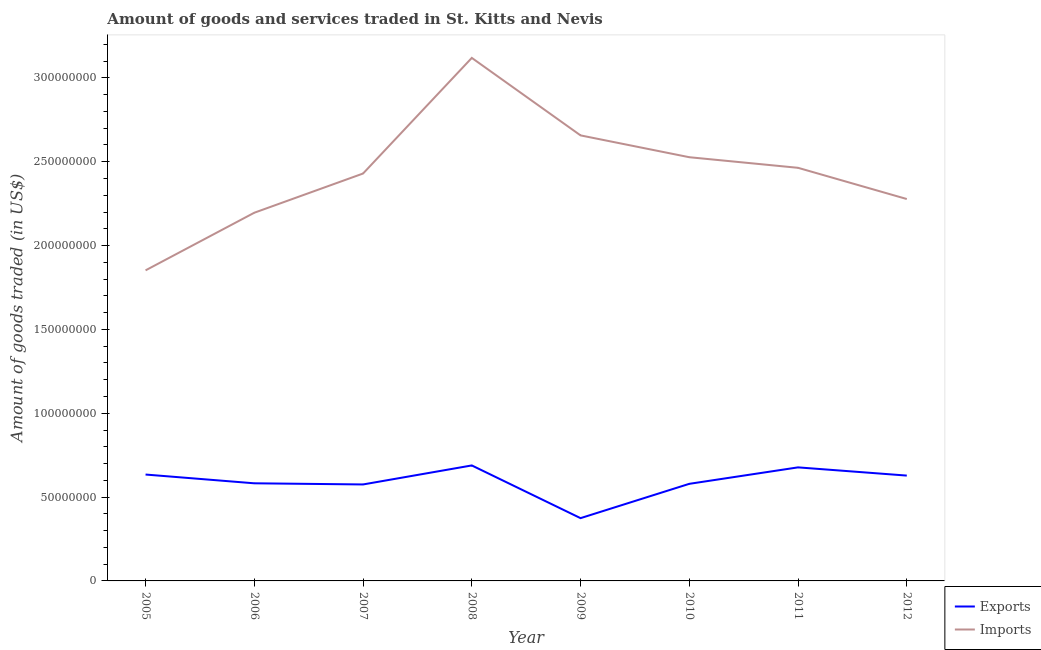Does the line corresponding to amount of goods imported intersect with the line corresponding to amount of goods exported?
Give a very brief answer. No. What is the amount of goods imported in 2008?
Make the answer very short. 3.12e+08. Across all years, what is the maximum amount of goods imported?
Your response must be concise. 3.12e+08. Across all years, what is the minimum amount of goods exported?
Make the answer very short. 3.74e+07. What is the total amount of goods imported in the graph?
Ensure brevity in your answer.  1.95e+09. What is the difference between the amount of goods imported in 2006 and that in 2011?
Ensure brevity in your answer.  -2.68e+07. What is the difference between the amount of goods imported in 2010 and the amount of goods exported in 2009?
Your answer should be compact. 2.15e+08. What is the average amount of goods imported per year?
Offer a very short reply. 2.44e+08. In the year 2009, what is the difference between the amount of goods exported and amount of goods imported?
Your answer should be very brief. -2.28e+08. What is the ratio of the amount of goods imported in 2005 to that in 2011?
Your response must be concise. 0.75. Is the difference between the amount of goods imported in 2008 and 2010 greater than the difference between the amount of goods exported in 2008 and 2010?
Give a very brief answer. Yes. What is the difference between the highest and the second highest amount of goods imported?
Provide a short and direct response. 4.62e+07. What is the difference between the highest and the lowest amount of goods imported?
Provide a succinct answer. 1.27e+08. Is the sum of the amount of goods imported in 2007 and 2008 greater than the maximum amount of goods exported across all years?
Ensure brevity in your answer.  Yes. Does the amount of goods imported monotonically increase over the years?
Ensure brevity in your answer.  No. Is the amount of goods exported strictly greater than the amount of goods imported over the years?
Provide a succinct answer. No. Is the amount of goods exported strictly less than the amount of goods imported over the years?
Make the answer very short. Yes. What is the difference between two consecutive major ticks on the Y-axis?
Ensure brevity in your answer.  5.00e+07. Does the graph contain any zero values?
Provide a short and direct response. No. How many legend labels are there?
Keep it short and to the point. 2. What is the title of the graph?
Give a very brief answer. Amount of goods and services traded in St. Kitts and Nevis. What is the label or title of the Y-axis?
Ensure brevity in your answer.  Amount of goods traded (in US$). What is the Amount of goods traded (in US$) of Exports in 2005?
Offer a terse response. 6.34e+07. What is the Amount of goods traded (in US$) in Imports in 2005?
Give a very brief answer. 1.85e+08. What is the Amount of goods traded (in US$) in Exports in 2006?
Your answer should be very brief. 5.82e+07. What is the Amount of goods traded (in US$) of Imports in 2006?
Keep it short and to the point. 2.20e+08. What is the Amount of goods traded (in US$) of Exports in 2007?
Give a very brief answer. 5.75e+07. What is the Amount of goods traded (in US$) of Imports in 2007?
Provide a succinct answer. 2.43e+08. What is the Amount of goods traded (in US$) in Exports in 2008?
Make the answer very short. 6.89e+07. What is the Amount of goods traded (in US$) of Imports in 2008?
Your answer should be very brief. 3.12e+08. What is the Amount of goods traded (in US$) of Exports in 2009?
Make the answer very short. 3.74e+07. What is the Amount of goods traded (in US$) of Imports in 2009?
Offer a very short reply. 2.66e+08. What is the Amount of goods traded (in US$) in Exports in 2010?
Your response must be concise. 5.79e+07. What is the Amount of goods traded (in US$) of Imports in 2010?
Keep it short and to the point. 2.53e+08. What is the Amount of goods traded (in US$) in Exports in 2011?
Offer a terse response. 6.77e+07. What is the Amount of goods traded (in US$) of Imports in 2011?
Your answer should be very brief. 2.46e+08. What is the Amount of goods traded (in US$) of Exports in 2012?
Your response must be concise. 6.28e+07. What is the Amount of goods traded (in US$) of Imports in 2012?
Ensure brevity in your answer.  2.28e+08. Across all years, what is the maximum Amount of goods traded (in US$) in Exports?
Provide a succinct answer. 6.89e+07. Across all years, what is the maximum Amount of goods traded (in US$) in Imports?
Offer a terse response. 3.12e+08. Across all years, what is the minimum Amount of goods traded (in US$) of Exports?
Ensure brevity in your answer.  3.74e+07. Across all years, what is the minimum Amount of goods traded (in US$) in Imports?
Keep it short and to the point. 1.85e+08. What is the total Amount of goods traded (in US$) in Exports in the graph?
Make the answer very short. 4.74e+08. What is the total Amount of goods traded (in US$) in Imports in the graph?
Offer a terse response. 1.95e+09. What is the difference between the Amount of goods traded (in US$) in Exports in 2005 and that in 2006?
Your response must be concise. 5.23e+06. What is the difference between the Amount of goods traded (in US$) in Imports in 2005 and that in 2006?
Give a very brief answer. -3.44e+07. What is the difference between the Amount of goods traded (in US$) of Exports in 2005 and that in 2007?
Give a very brief answer. 5.92e+06. What is the difference between the Amount of goods traded (in US$) of Imports in 2005 and that in 2007?
Your answer should be very brief. -5.77e+07. What is the difference between the Amount of goods traded (in US$) of Exports in 2005 and that in 2008?
Keep it short and to the point. -5.43e+06. What is the difference between the Amount of goods traded (in US$) of Imports in 2005 and that in 2008?
Your response must be concise. -1.27e+08. What is the difference between the Amount of goods traded (in US$) in Exports in 2005 and that in 2009?
Your answer should be compact. 2.60e+07. What is the difference between the Amount of goods traded (in US$) in Imports in 2005 and that in 2009?
Your answer should be compact. -8.05e+07. What is the difference between the Amount of goods traded (in US$) of Exports in 2005 and that in 2010?
Provide a short and direct response. 5.54e+06. What is the difference between the Amount of goods traded (in US$) in Imports in 2005 and that in 2010?
Make the answer very short. -6.75e+07. What is the difference between the Amount of goods traded (in US$) in Exports in 2005 and that in 2011?
Ensure brevity in your answer.  -4.27e+06. What is the difference between the Amount of goods traded (in US$) in Imports in 2005 and that in 2011?
Provide a succinct answer. -6.11e+07. What is the difference between the Amount of goods traded (in US$) of Exports in 2005 and that in 2012?
Provide a short and direct response. 6.25e+05. What is the difference between the Amount of goods traded (in US$) in Imports in 2005 and that in 2012?
Give a very brief answer. -4.25e+07. What is the difference between the Amount of goods traded (in US$) in Exports in 2006 and that in 2007?
Offer a very short reply. 6.88e+05. What is the difference between the Amount of goods traded (in US$) in Imports in 2006 and that in 2007?
Make the answer very short. -2.34e+07. What is the difference between the Amount of goods traded (in US$) in Exports in 2006 and that in 2008?
Provide a short and direct response. -1.07e+07. What is the difference between the Amount of goods traded (in US$) in Imports in 2006 and that in 2008?
Provide a succinct answer. -9.23e+07. What is the difference between the Amount of goods traded (in US$) of Exports in 2006 and that in 2009?
Keep it short and to the point. 2.08e+07. What is the difference between the Amount of goods traded (in US$) of Imports in 2006 and that in 2009?
Keep it short and to the point. -4.61e+07. What is the difference between the Amount of goods traded (in US$) of Exports in 2006 and that in 2010?
Offer a terse response. 3.13e+05. What is the difference between the Amount of goods traded (in US$) of Imports in 2006 and that in 2010?
Offer a very short reply. -3.31e+07. What is the difference between the Amount of goods traded (in US$) of Exports in 2006 and that in 2011?
Your answer should be very brief. -9.50e+06. What is the difference between the Amount of goods traded (in US$) of Imports in 2006 and that in 2011?
Ensure brevity in your answer.  -2.68e+07. What is the difference between the Amount of goods traded (in US$) of Exports in 2006 and that in 2012?
Provide a succinct answer. -4.60e+06. What is the difference between the Amount of goods traded (in US$) in Imports in 2006 and that in 2012?
Offer a terse response. -8.17e+06. What is the difference between the Amount of goods traded (in US$) in Exports in 2007 and that in 2008?
Give a very brief answer. -1.13e+07. What is the difference between the Amount of goods traded (in US$) of Imports in 2007 and that in 2008?
Offer a very short reply. -6.90e+07. What is the difference between the Amount of goods traded (in US$) of Exports in 2007 and that in 2009?
Your response must be concise. 2.01e+07. What is the difference between the Amount of goods traded (in US$) in Imports in 2007 and that in 2009?
Your response must be concise. -2.27e+07. What is the difference between the Amount of goods traded (in US$) of Exports in 2007 and that in 2010?
Your answer should be compact. -3.75e+05. What is the difference between the Amount of goods traded (in US$) in Imports in 2007 and that in 2010?
Make the answer very short. -9.72e+06. What is the difference between the Amount of goods traded (in US$) in Exports in 2007 and that in 2011?
Offer a terse response. -1.02e+07. What is the difference between the Amount of goods traded (in US$) of Imports in 2007 and that in 2011?
Make the answer very short. -3.40e+06. What is the difference between the Amount of goods traded (in US$) in Exports in 2007 and that in 2012?
Your answer should be compact. -5.29e+06. What is the difference between the Amount of goods traded (in US$) of Imports in 2007 and that in 2012?
Provide a short and direct response. 1.52e+07. What is the difference between the Amount of goods traded (in US$) in Exports in 2008 and that in 2009?
Ensure brevity in your answer.  3.14e+07. What is the difference between the Amount of goods traded (in US$) of Imports in 2008 and that in 2009?
Your response must be concise. 4.62e+07. What is the difference between the Amount of goods traded (in US$) in Exports in 2008 and that in 2010?
Provide a short and direct response. 1.10e+07. What is the difference between the Amount of goods traded (in US$) in Imports in 2008 and that in 2010?
Make the answer very short. 5.92e+07. What is the difference between the Amount of goods traded (in US$) in Exports in 2008 and that in 2011?
Your response must be concise. 1.15e+06. What is the difference between the Amount of goods traded (in US$) in Imports in 2008 and that in 2011?
Ensure brevity in your answer.  6.56e+07. What is the difference between the Amount of goods traded (in US$) in Exports in 2008 and that in 2012?
Give a very brief answer. 6.05e+06. What is the difference between the Amount of goods traded (in US$) of Imports in 2008 and that in 2012?
Your answer should be compact. 8.42e+07. What is the difference between the Amount of goods traded (in US$) in Exports in 2009 and that in 2010?
Offer a terse response. -2.05e+07. What is the difference between the Amount of goods traded (in US$) of Imports in 2009 and that in 2010?
Your answer should be compact. 1.30e+07. What is the difference between the Amount of goods traded (in US$) in Exports in 2009 and that in 2011?
Offer a terse response. -3.03e+07. What is the difference between the Amount of goods traded (in US$) of Imports in 2009 and that in 2011?
Provide a short and direct response. 1.93e+07. What is the difference between the Amount of goods traded (in US$) of Exports in 2009 and that in 2012?
Offer a very short reply. -2.54e+07. What is the difference between the Amount of goods traded (in US$) of Imports in 2009 and that in 2012?
Ensure brevity in your answer.  3.79e+07. What is the difference between the Amount of goods traded (in US$) of Exports in 2010 and that in 2011?
Your answer should be very brief. -9.81e+06. What is the difference between the Amount of goods traded (in US$) of Imports in 2010 and that in 2011?
Keep it short and to the point. 6.32e+06. What is the difference between the Amount of goods traded (in US$) in Exports in 2010 and that in 2012?
Offer a very short reply. -4.91e+06. What is the difference between the Amount of goods traded (in US$) in Imports in 2010 and that in 2012?
Make the answer very short. 2.49e+07. What is the difference between the Amount of goods traded (in US$) in Exports in 2011 and that in 2012?
Provide a succinct answer. 4.90e+06. What is the difference between the Amount of goods traded (in US$) in Imports in 2011 and that in 2012?
Give a very brief answer. 1.86e+07. What is the difference between the Amount of goods traded (in US$) of Exports in 2005 and the Amount of goods traded (in US$) of Imports in 2006?
Provide a succinct answer. -1.56e+08. What is the difference between the Amount of goods traded (in US$) in Exports in 2005 and the Amount of goods traded (in US$) in Imports in 2007?
Keep it short and to the point. -1.80e+08. What is the difference between the Amount of goods traded (in US$) in Exports in 2005 and the Amount of goods traded (in US$) in Imports in 2008?
Offer a very short reply. -2.48e+08. What is the difference between the Amount of goods traded (in US$) of Exports in 2005 and the Amount of goods traded (in US$) of Imports in 2009?
Your response must be concise. -2.02e+08. What is the difference between the Amount of goods traded (in US$) of Exports in 2005 and the Amount of goods traded (in US$) of Imports in 2010?
Make the answer very short. -1.89e+08. What is the difference between the Amount of goods traded (in US$) in Exports in 2005 and the Amount of goods traded (in US$) in Imports in 2011?
Keep it short and to the point. -1.83e+08. What is the difference between the Amount of goods traded (in US$) in Exports in 2005 and the Amount of goods traded (in US$) in Imports in 2012?
Offer a terse response. -1.64e+08. What is the difference between the Amount of goods traded (in US$) of Exports in 2006 and the Amount of goods traded (in US$) of Imports in 2007?
Your response must be concise. -1.85e+08. What is the difference between the Amount of goods traded (in US$) of Exports in 2006 and the Amount of goods traded (in US$) of Imports in 2008?
Your response must be concise. -2.54e+08. What is the difference between the Amount of goods traded (in US$) of Exports in 2006 and the Amount of goods traded (in US$) of Imports in 2009?
Offer a terse response. -2.07e+08. What is the difference between the Amount of goods traded (in US$) in Exports in 2006 and the Amount of goods traded (in US$) in Imports in 2010?
Provide a succinct answer. -1.94e+08. What is the difference between the Amount of goods traded (in US$) in Exports in 2006 and the Amount of goods traded (in US$) in Imports in 2011?
Keep it short and to the point. -1.88e+08. What is the difference between the Amount of goods traded (in US$) of Exports in 2006 and the Amount of goods traded (in US$) of Imports in 2012?
Keep it short and to the point. -1.70e+08. What is the difference between the Amount of goods traded (in US$) in Exports in 2007 and the Amount of goods traded (in US$) in Imports in 2008?
Keep it short and to the point. -2.54e+08. What is the difference between the Amount of goods traded (in US$) of Exports in 2007 and the Amount of goods traded (in US$) of Imports in 2009?
Keep it short and to the point. -2.08e+08. What is the difference between the Amount of goods traded (in US$) in Exports in 2007 and the Amount of goods traded (in US$) in Imports in 2010?
Provide a short and direct response. -1.95e+08. What is the difference between the Amount of goods traded (in US$) in Exports in 2007 and the Amount of goods traded (in US$) in Imports in 2011?
Give a very brief answer. -1.89e+08. What is the difference between the Amount of goods traded (in US$) of Exports in 2007 and the Amount of goods traded (in US$) of Imports in 2012?
Offer a terse response. -1.70e+08. What is the difference between the Amount of goods traded (in US$) of Exports in 2008 and the Amount of goods traded (in US$) of Imports in 2009?
Keep it short and to the point. -1.97e+08. What is the difference between the Amount of goods traded (in US$) of Exports in 2008 and the Amount of goods traded (in US$) of Imports in 2010?
Keep it short and to the point. -1.84e+08. What is the difference between the Amount of goods traded (in US$) in Exports in 2008 and the Amount of goods traded (in US$) in Imports in 2011?
Ensure brevity in your answer.  -1.77e+08. What is the difference between the Amount of goods traded (in US$) of Exports in 2008 and the Amount of goods traded (in US$) of Imports in 2012?
Provide a short and direct response. -1.59e+08. What is the difference between the Amount of goods traded (in US$) of Exports in 2009 and the Amount of goods traded (in US$) of Imports in 2010?
Your answer should be very brief. -2.15e+08. What is the difference between the Amount of goods traded (in US$) of Exports in 2009 and the Amount of goods traded (in US$) of Imports in 2011?
Offer a terse response. -2.09e+08. What is the difference between the Amount of goods traded (in US$) in Exports in 2009 and the Amount of goods traded (in US$) in Imports in 2012?
Ensure brevity in your answer.  -1.90e+08. What is the difference between the Amount of goods traded (in US$) in Exports in 2010 and the Amount of goods traded (in US$) in Imports in 2011?
Provide a short and direct response. -1.88e+08. What is the difference between the Amount of goods traded (in US$) of Exports in 2010 and the Amount of goods traded (in US$) of Imports in 2012?
Keep it short and to the point. -1.70e+08. What is the difference between the Amount of goods traded (in US$) in Exports in 2011 and the Amount of goods traded (in US$) in Imports in 2012?
Keep it short and to the point. -1.60e+08. What is the average Amount of goods traded (in US$) in Exports per year?
Make the answer very short. 5.92e+07. What is the average Amount of goods traded (in US$) in Imports per year?
Your answer should be very brief. 2.44e+08. In the year 2005, what is the difference between the Amount of goods traded (in US$) of Exports and Amount of goods traded (in US$) of Imports?
Your answer should be very brief. -1.22e+08. In the year 2006, what is the difference between the Amount of goods traded (in US$) of Exports and Amount of goods traded (in US$) of Imports?
Provide a succinct answer. -1.61e+08. In the year 2007, what is the difference between the Amount of goods traded (in US$) of Exports and Amount of goods traded (in US$) of Imports?
Ensure brevity in your answer.  -1.85e+08. In the year 2008, what is the difference between the Amount of goods traded (in US$) in Exports and Amount of goods traded (in US$) in Imports?
Offer a terse response. -2.43e+08. In the year 2009, what is the difference between the Amount of goods traded (in US$) of Exports and Amount of goods traded (in US$) of Imports?
Make the answer very short. -2.28e+08. In the year 2010, what is the difference between the Amount of goods traded (in US$) of Exports and Amount of goods traded (in US$) of Imports?
Your answer should be compact. -1.95e+08. In the year 2011, what is the difference between the Amount of goods traded (in US$) of Exports and Amount of goods traded (in US$) of Imports?
Provide a short and direct response. -1.79e+08. In the year 2012, what is the difference between the Amount of goods traded (in US$) in Exports and Amount of goods traded (in US$) in Imports?
Give a very brief answer. -1.65e+08. What is the ratio of the Amount of goods traded (in US$) in Exports in 2005 to that in 2006?
Give a very brief answer. 1.09. What is the ratio of the Amount of goods traded (in US$) of Imports in 2005 to that in 2006?
Give a very brief answer. 0.84. What is the ratio of the Amount of goods traded (in US$) in Exports in 2005 to that in 2007?
Offer a very short reply. 1.1. What is the ratio of the Amount of goods traded (in US$) of Imports in 2005 to that in 2007?
Your answer should be very brief. 0.76. What is the ratio of the Amount of goods traded (in US$) of Exports in 2005 to that in 2008?
Your answer should be compact. 0.92. What is the ratio of the Amount of goods traded (in US$) of Imports in 2005 to that in 2008?
Make the answer very short. 0.59. What is the ratio of the Amount of goods traded (in US$) in Exports in 2005 to that in 2009?
Provide a short and direct response. 1.69. What is the ratio of the Amount of goods traded (in US$) in Imports in 2005 to that in 2009?
Provide a succinct answer. 0.7. What is the ratio of the Amount of goods traded (in US$) in Exports in 2005 to that in 2010?
Ensure brevity in your answer.  1.1. What is the ratio of the Amount of goods traded (in US$) in Imports in 2005 to that in 2010?
Provide a short and direct response. 0.73. What is the ratio of the Amount of goods traded (in US$) in Exports in 2005 to that in 2011?
Give a very brief answer. 0.94. What is the ratio of the Amount of goods traded (in US$) in Imports in 2005 to that in 2011?
Provide a succinct answer. 0.75. What is the ratio of the Amount of goods traded (in US$) of Exports in 2005 to that in 2012?
Keep it short and to the point. 1.01. What is the ratio of the Amount of goods traded (in US$) of Imports in 2005 to that in 2012?
Your response must be concise. 0.81. What is the ratio of the Amount of goods traded (in US$) in Imports in 2006 to that in 2007?
Your answer should be compact. 0.9. What is the ratio of the Amount of goods traded (in US$) in Exports in 2006 to that in 2008?
Make the answer very short. 0.85. What is the ratio of the Amount of goods traded (in US$) of Imports in 2006 to that in 2008?
Ensure brevity in your answer.  0.7. What is the ratio of the Amount of goods traded (in US$) of Exports in 2006 to that in 2009?
Offer a terse response. 1.55. What is the ratio of the Amount of goods traded (in US$) of Imports in 2006 to that in 2009?
Your answer should be compact. 0.83. What is the ratio of the Amount of goods traded (in US$) in Exports in 2006 to that in 2010?
Provide a short and direct response. 1.01. What is the ratio of the Amount of goods traded (in US$) in Imports in 2006 to that in 2010?
Keep it short and to the point. 0.87. What is the ratio of the Amount of goods traded (in US$) of Exports in 2006 to that in 2011?
Keep it short and to the point. 0.86. What is the ratio of the Amount of goods traded (in US$) in Imports in 2006 to that in 2011?
Your answer should be very brief. 0.89. What is the ratio of the Amount of goods traded (in US$) in Exports in 2006 to that in 2012?
Provide a succinct answer. 0.93. What is the ratio of the Amount of goods traded (in US$) in Imports in 2006 to that in 2012?
Ensure brevity in your answer.  0.96. What is the ratio of the Amount of goods traded (in US$) in Exports in 2007 to that in 2008?
Make the answer very short. 0.84. What is the ratio of the Amount of goods traded (in US$) of Imports in 2007 to that in 2008?
Provide a succinct answer. 0.78. What is the ratio of the Amount of goods traded (in US$) of Exports in 2007 to that in 2009?
Make the answer very short. 1.54. What is the ratio of the Amount of goods traded (in US$) in Imports in 2007 to that in 2009?
Your response must be concise. 0.91. What is the ratio of the Amount of goods traded (in US$) of Imports in 2007 to that in 2010?
Your answer should be compact. 0.96. What is the ratio of the Amount of goods traded (in US$) in Exports in 2007 to that in 2011?
Make the answer very short. 0.85. What is the ratio of the Amount of goods traded (in US$) of Imports in 2007 to that in 2011?
Provide a succinct answer. 0.99. What is the ratio of the Amount of goods traded (in US$) in Exports in 2007 to that in 2012?
Ensure brevity in your answer.  0.92. What is the ratio of the Amount of goods traded (in US$) in Imports in 2007 to that in 2012?
Offer a terse response. 1.07. What is the ratio of the Amount of goods traded (in US$) of Exports in 2008 to that in 2009?
Make the answer very short. 1.84. What is the ratio of the Amount of goods traded (in US$) in Imports in 2008 to that in 2009?
Provide a short and direct response. 1.17. What is the ratio of the Amount of goods traded (in US$) of Exports in 2008 to that in 2010?
Provide a short and direct response. 1.19. What is the ratio of the Amount of goods traded (in US$) in Imports in 2008 to that in 2010?
Offer a very short reply. 1.23. What is the ratio of the Amount of goods traded (in US$) in Exports in 2008 to that in 2011?
Your answer should be very brief. 1.02. What is the ratio of the Amount of goods traded (in US$) of Imports in 2008 to that in 2011?
Ensure brevity in your answer.  1.27. What is the ratio of the Amount of goods traded (in US$) in Exports in 2008 to that in 2012?
Offer a very short reply. 1.1. What is the ratio of the Amount of goods traded (in US$) in Imports in 2008 to that in 2012?
Provide a succinct answer. 1.37. What is the ratio of the Amount of goods traded (in US$) in Exports in 2009 to that in 2010?
Offer a very short reply. 0.65. What is the ratio of the Amount of goods traded (in US$) in Imports in 2009 to that in 2010?
Ensure brevity in your answer.  1.05. What is the ratio of the Amount of goods traded (in US$) of Exports in 2009 to that in 2011?
Your answer should be very brief. 0.55. What is the ratio of the Amount of goods traded (in US$) of Imports in 2009 to that in 2011?
Give a very brief answer. 1.08. What is the ratio of the Amount of goods traded (in US$) of Exports in 2009 to that in 2012?
Make the answer very short. 0.6. What is the ratio of the Amount of goods traded (in US$) of Imports in 2009 to that in 2012?
Give a very brief answer. 1.17. What is the ratio of the Amount of goods traded (in US$) of Exports in 2010 to that in 2011?
Your answer should be very brief. 0.86. What is the ratio of the Amount of goods traded (in US$) of Imports in 2010 to that in 2011?
Ensure brevity in your answer.  1.03. What is the ratio of the Amount of goods traded (in US$) of Exports in 2010 to that in 2012?
Provide a short and direct response. 0.92. What is the ratio of the Amount of goods traded (in US$) of Imports in 2010 to that in 2012?
Provide a short and direct response. 1.11. What is the ratio of the Amount of goods traded (in US$) of Exports in 2011 to that in 2012?
Your answer should be compact. 1.08. What is the ratio of the Amount of goods traded (in US$) of Imports in 2011 to that in 2012?
Keep it short and to the point. 1.08. What is the difference between the highest and the second highest Amount of goods traded (in US$) in Exports?
Ensure brevity in your answer.  1.15e+06. What is the difference between the highest and the second highest Amount of goods traded (in US$) in Imports?
Provide a succinct answer. 4.62e+07. What is the difference between the highest and the lowest Amount of goods traded (in US$) in Exports?
Offer a very short reply. 3.14e+07. What is the difference between the highest and the lowest Amount of goods traded (in US$) of Imports?
Your answer should be compact. 1.27e+08. 